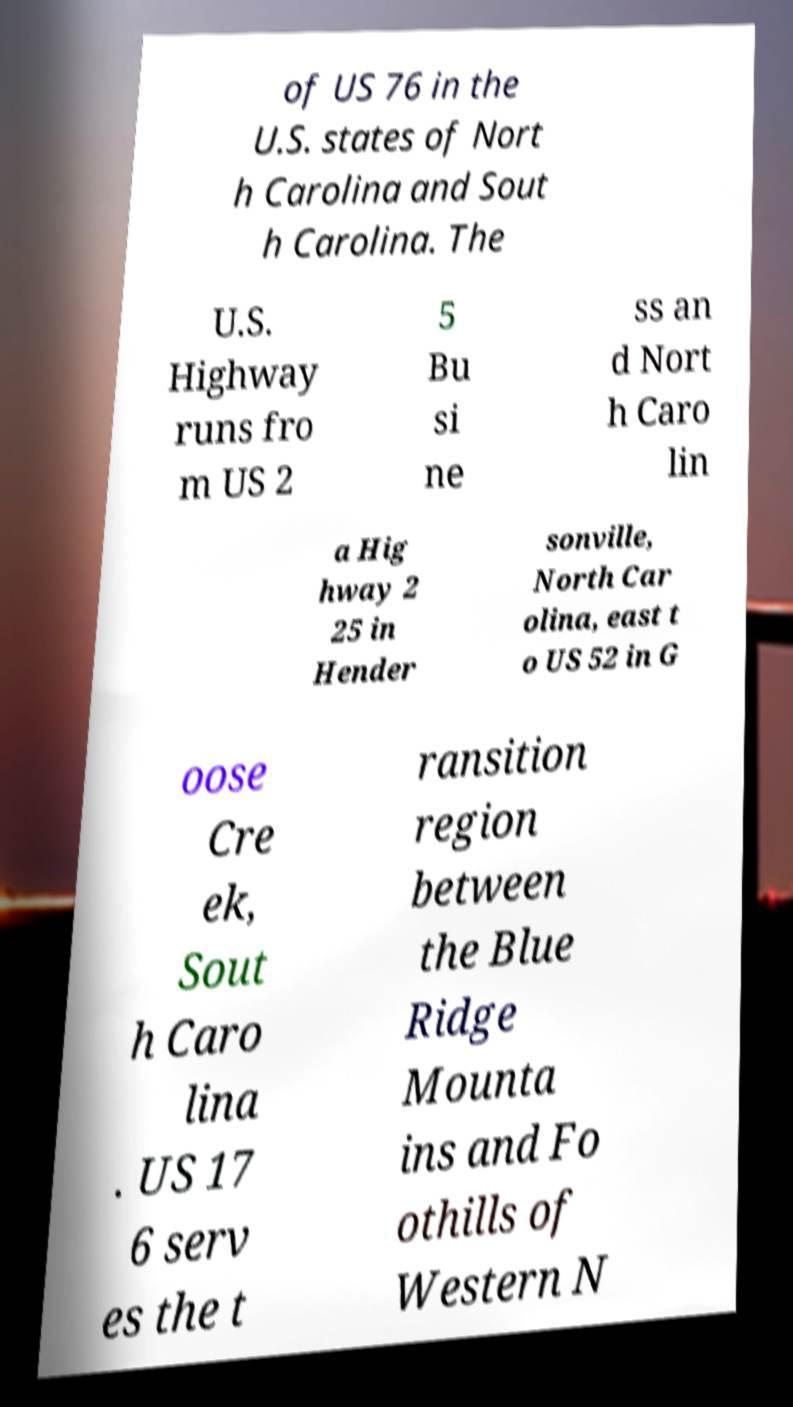Can you read and provide the text displayed in the image?This photo seems to have some interesting text. Can you extract and type it out for me? of US 76 in the U.S. states of Nort h Carolina and Sout h Carolina. The U.S. Highway runs fro m US 2 5 Bu si ne ss an d Nort h Caro lin a Hig hway 2 25 in Hender sonville, North Car olina, east t o US 52 in G oose Cre ek, Sout h Caro lina . US 17 6 serv es the t ransition region between the Blue Ridge Mounta ins and Fo othills of Western N 